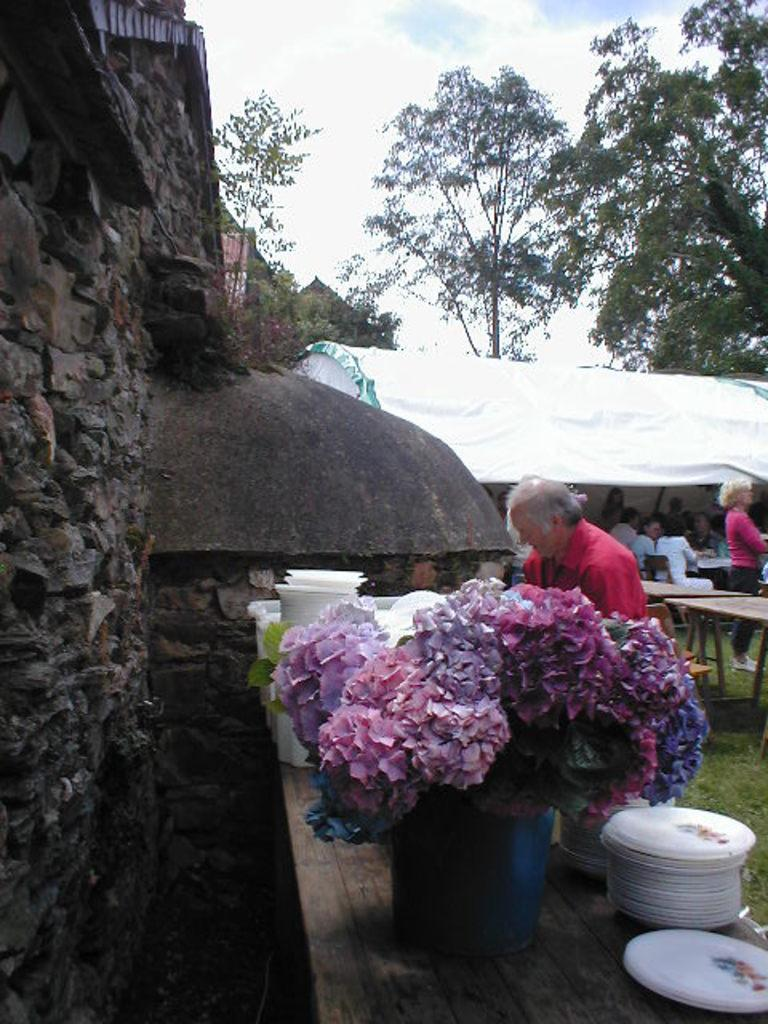What type of structure is on the left side of the image? There is a brick wall on the left side of the image. What object can be seen in the image that people might use for eating or serving food? There is a table in the image. What items are on the table? The table has plates on it and a flower vase. What can be seen in the background of the image? There is a group of people and trees in the background of the image. Is there a servant in the image wearing a sweater? There is no servant or sweater present in the image. What type of house is shown in the image? The image does not show a house; it only shows a brick wall, a table, and a background with people and trees. 